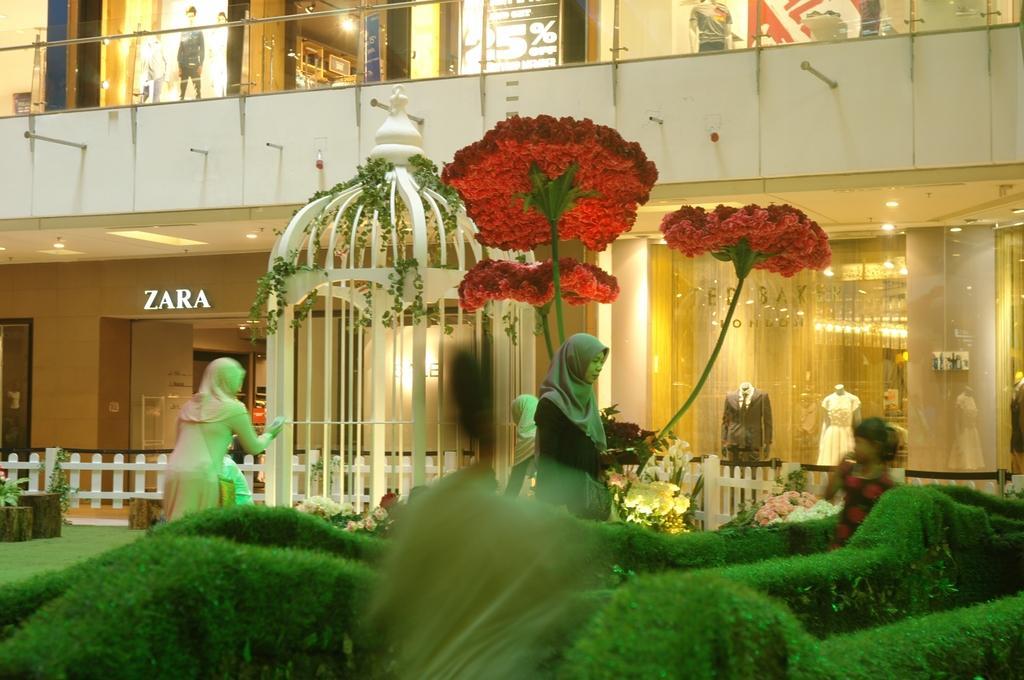In one or two sentences, can you explain what this image depicts? In front of the image there is grass. In the center of the image there is a cage. There are depictions of flowers. There are people. Behind the cage there is a fence. There are plants. In the background of the image there are stores. There is a glass railing. 